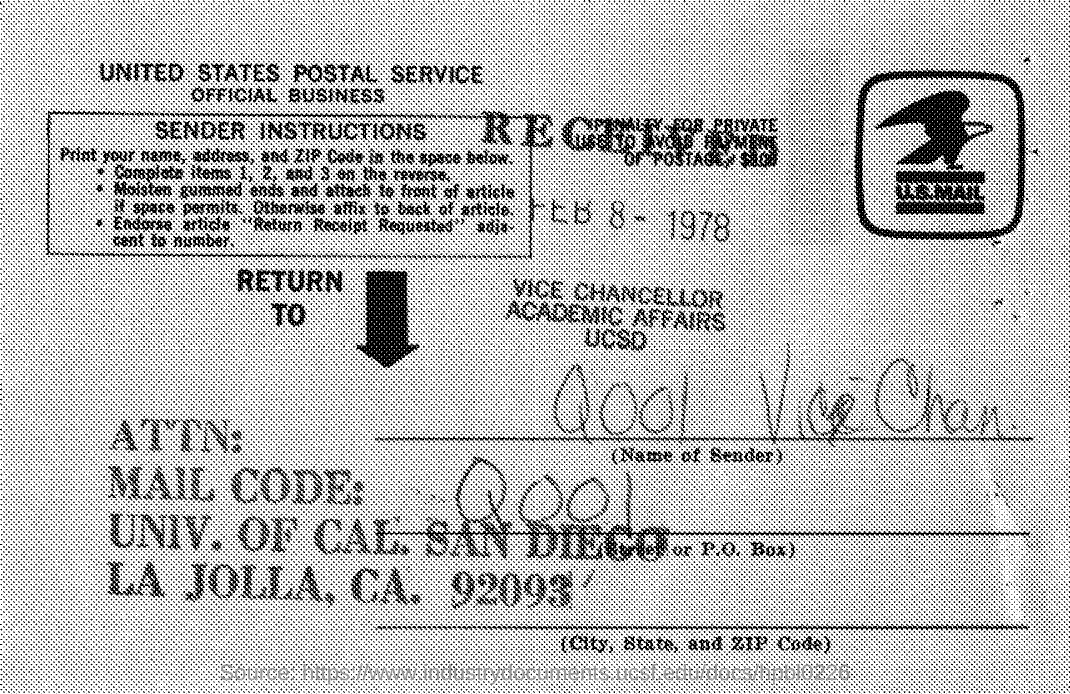What is the mail code mentioned in the given post ?
Provide a succinct answer. Q001. What is the name of the service mentioned in the post ?
Ensure brevity in your answer.  United states postal service. 